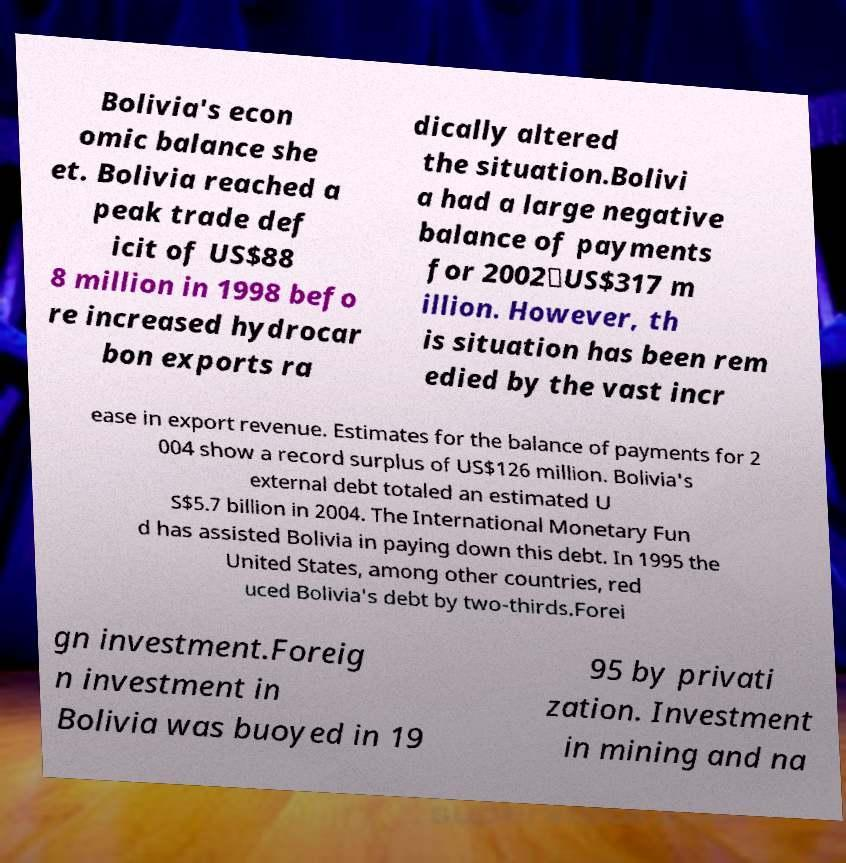For documentation purposes, I need the text within this image transcribed. Could you provide that? Bolivia's econ omic balance she et. Bolivia reached a peak trade def icit of US$88 8 million in 1998 befo re increased hydrocar bon exports ra dically altered the situation.Bolivi a had a large negative balance of payments for 2002⎯US$317 m illion. However, th is situation has been rem edied by the vast incr ease in export revenue. Estimates for the balance of payments for 2 004 show a record surplus of US$126 million. Bolivia's external debt totaled an estimated U S$5.7 billion in 2004. The International Monetary Fun d has assisted Bolivia in paying down this debt. In 1995 the United States, among other countries, red uced Bolivia's debt by two-thirds.Forei gn investment.Foreig n investment in Bolivia was buoyed in 19 95 by privati zation. Investment in mining and na 